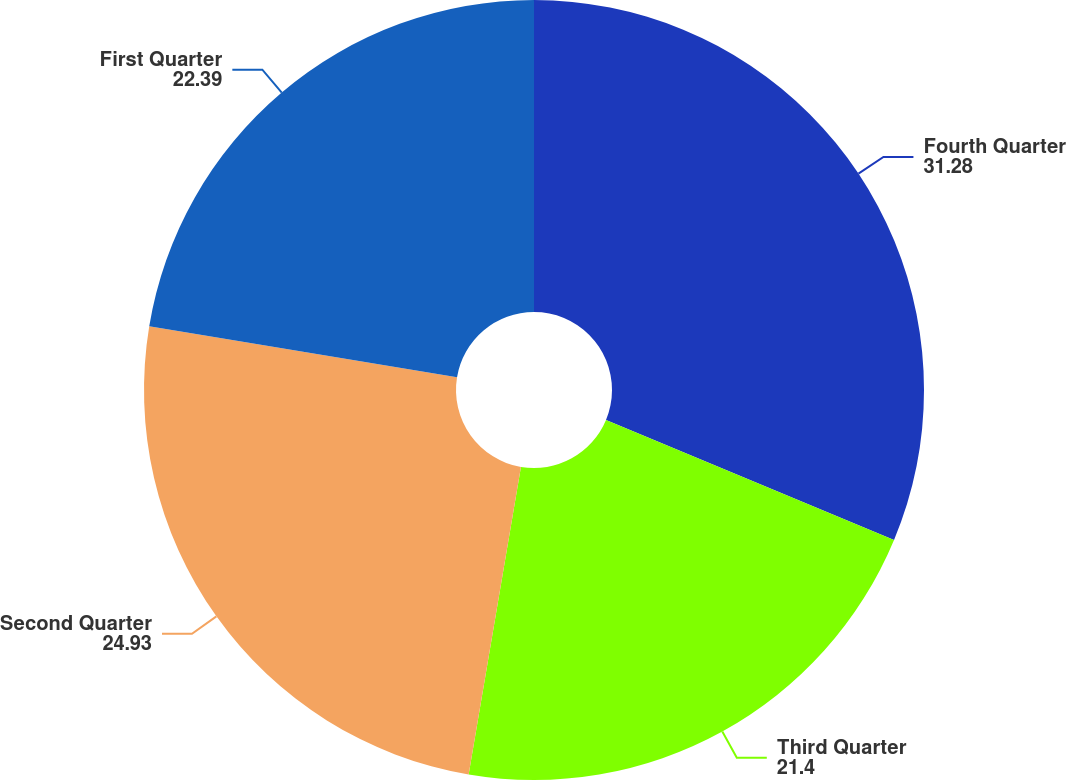Convert chart. <chart><loc_0><loc_0><loc_500><loc_500><pie_chart><fcel>Fourth Quarter<fcel>Third Quarter<fcel>Second Quarter<fcel>First Quarter<nl><fcel>31.28%<fcel>21.4%<fcel>24.93%<fcel>22.39%<nl></chart> 